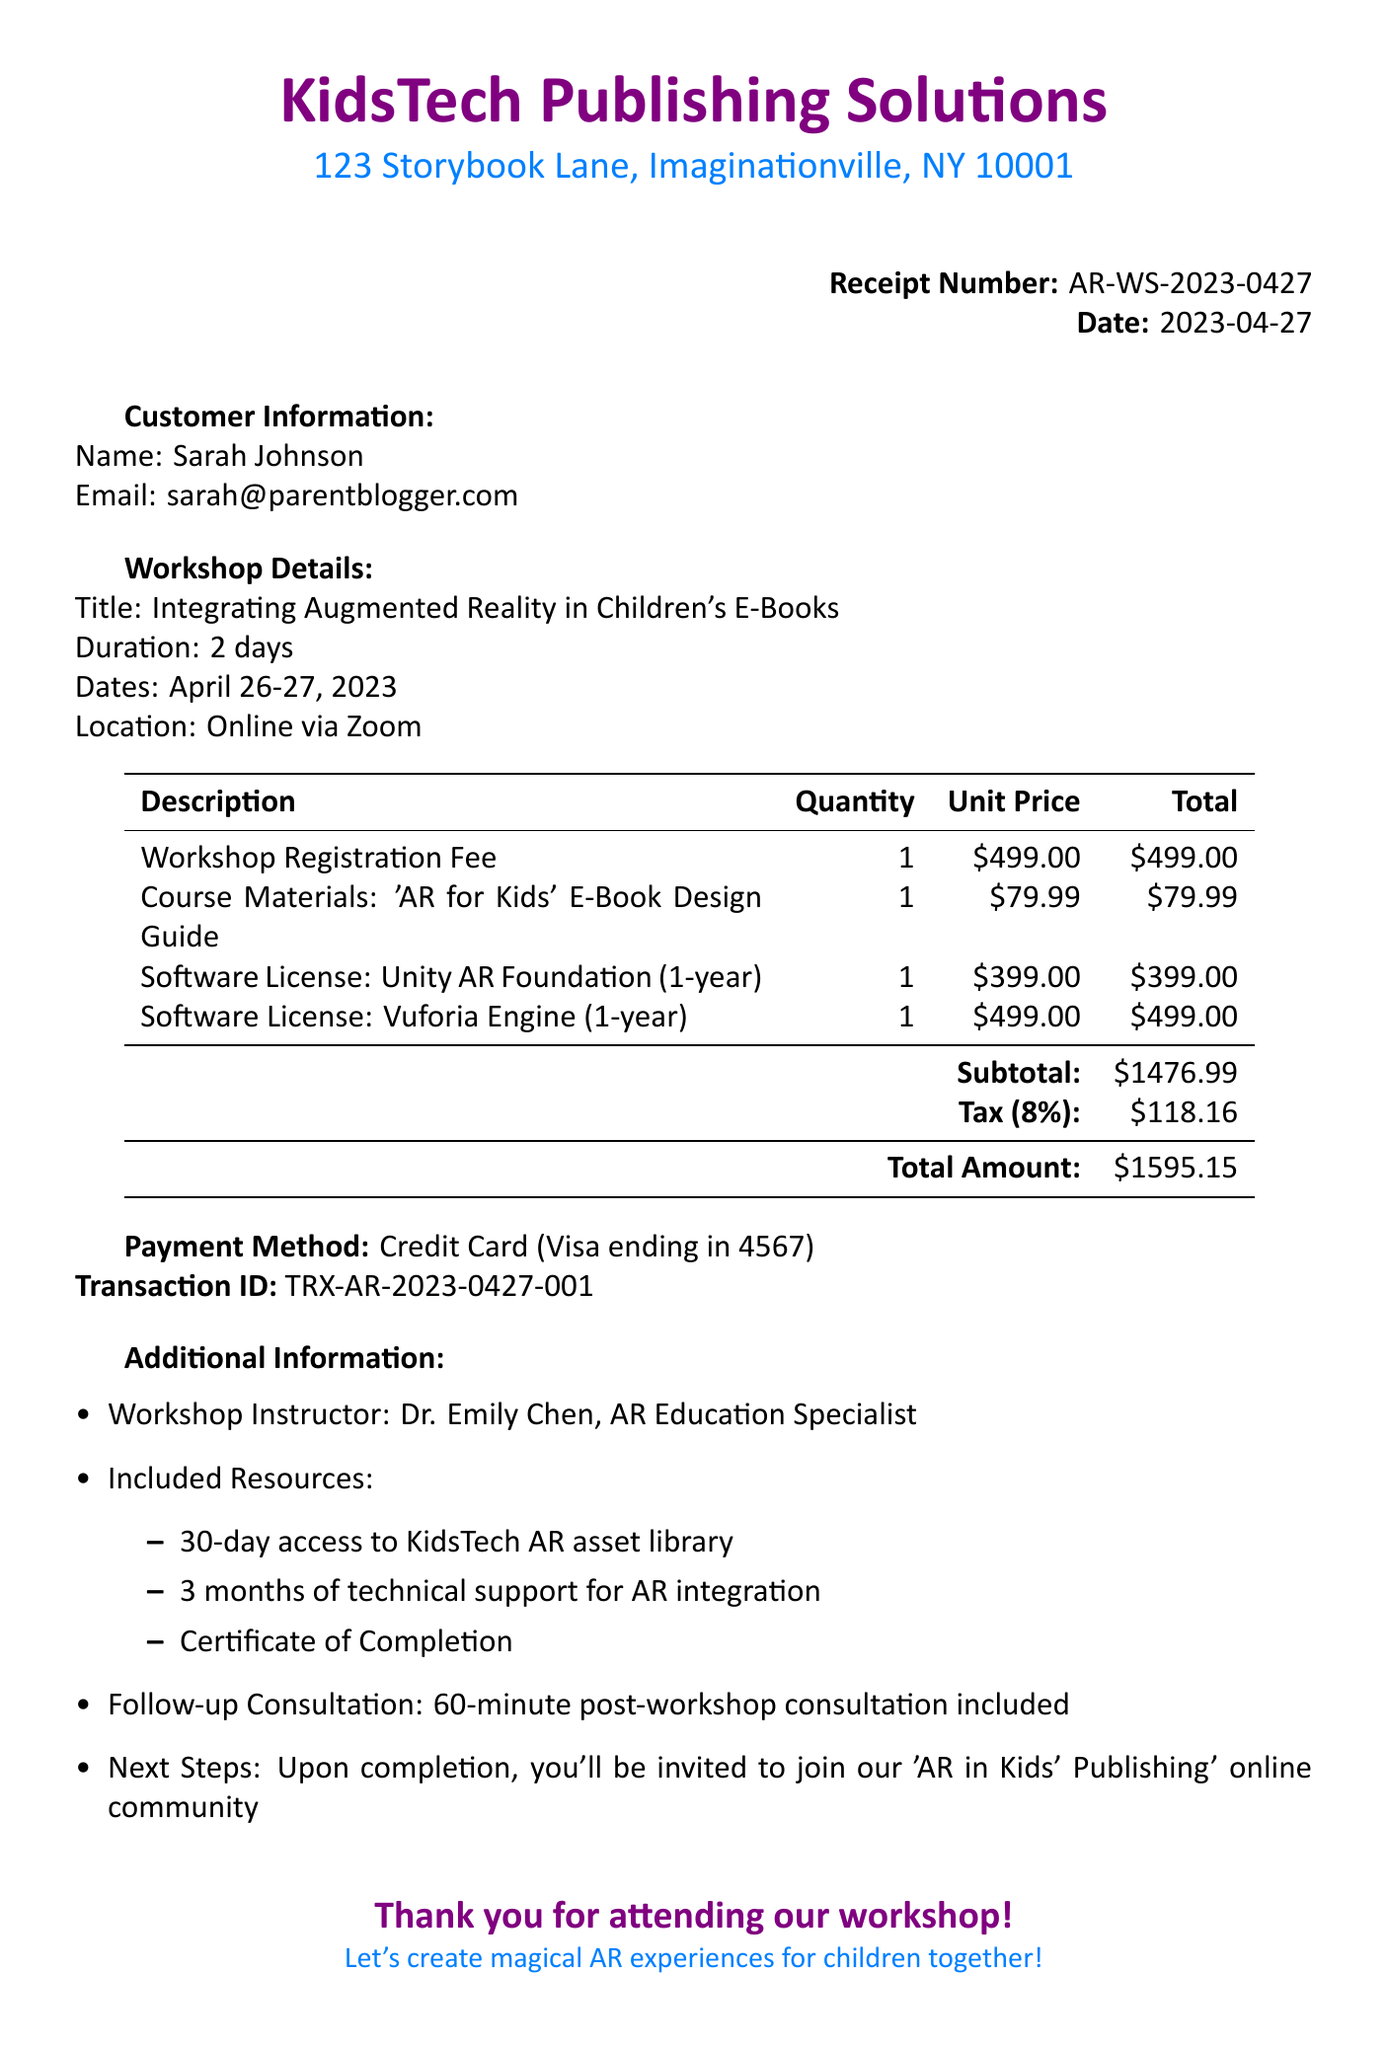What is the workshop title? The title of the workshop is specified in the document under workshop details.
Answer: Integrating Augmented Reality in Children's E-Books Who is the instructor of the workshop? The instructor's name is mentioned in the additional information section.
Answer: Dr. Emily Chen What is the total amount charged? The total amount is calculated at the bottom of the receipt.
Answer: $1595.15 How many months of technical support are included? The duration of support is detailed in the additional information section.
Answer: 3 months What payment method was used? The payment method is indicated in the payment section of the document.
Answer: Credit Card (Visa ending in 4567) What is the quantity for the 'AR for Kids' E-Book Design Guide? The quantity of this specific item is listed in the items table.
Answer: 1 What is the subtotal before tax? The subtotal is provided in the summary section of the receipt.
Answer: $1476.99 On which dates was the workshop held? The dates of the workshop are specified in the workshop details section.
Answer: April 26-27, 2023 What is included in the follow-up consultation? The type of follow-up consultation is outlined in the additional information.
Answer: 60-minute post-workshop consultation included 